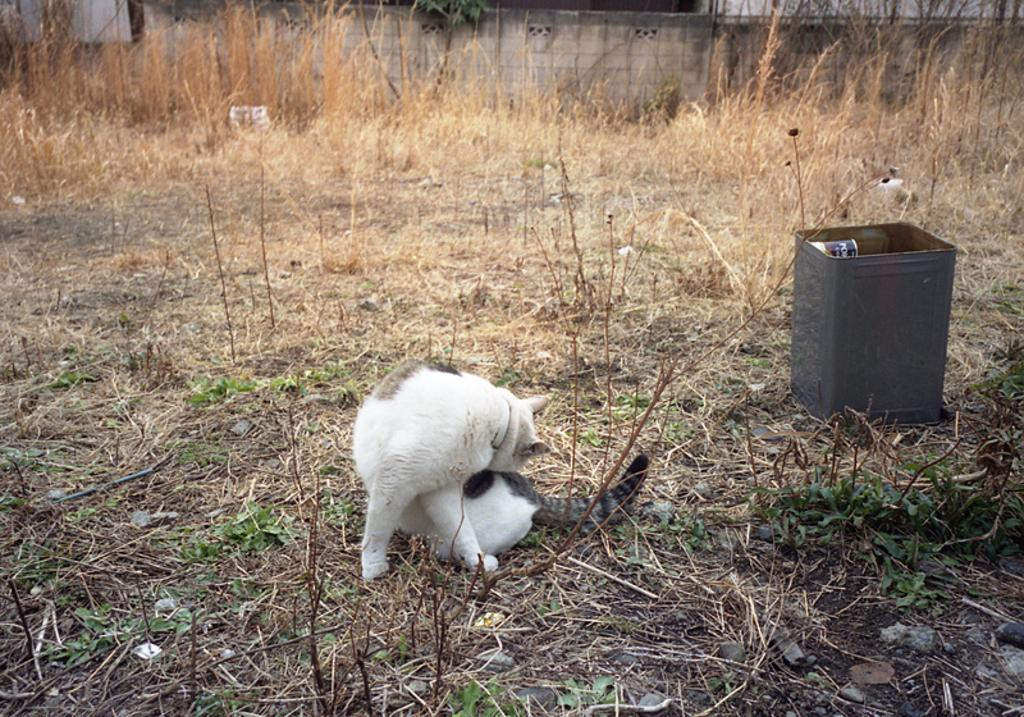What is the main subject in the center of the image? There is a cat in the center of the image. What type of vegetation is at the bottom of the image? There is grass at the bottom of the image. What other plants can be seen in the image besides grass? Shrubs are visible in the image. What object is on the right side of the image? There is a tin on the right side of the image. What is visible in the background of the image? There is a wall in the background of the image. How many houses are visible in the image? There are no houses visible in the image. What type of cord is being used by the cat in the image? There is no cord present in the image; the cat is not using any cord. 